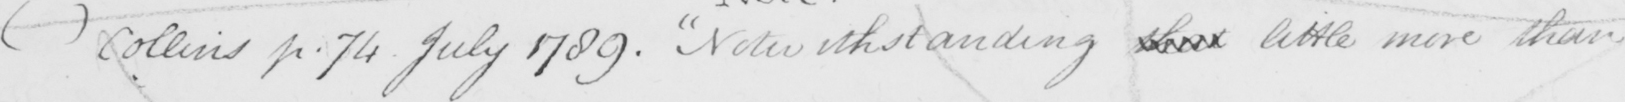Please provide the text content of this handwritten line. (   )  Collins p . 74 July 1789 . Notwithstanding that little more than 